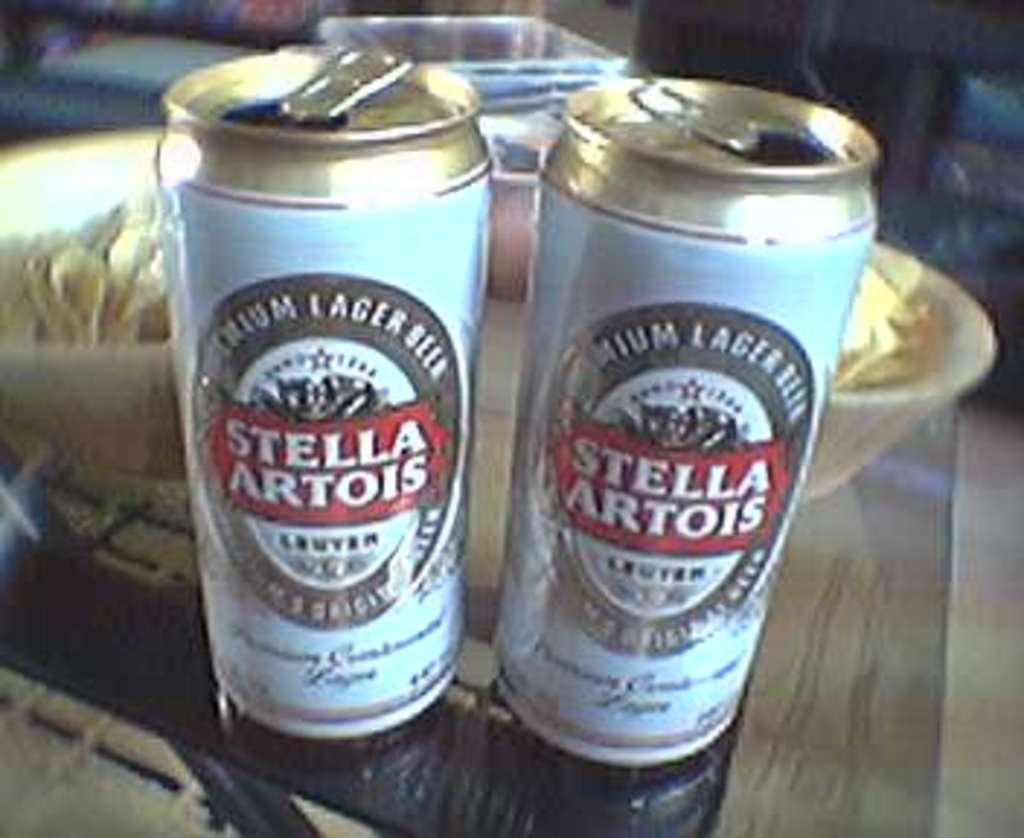<image>
Present a compact description of the photo's key features. Two open cans sitting on a table that are labeled Stell Artois. 